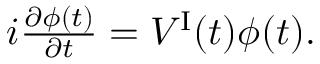Convert formula to latex. <formula><loc_0><loc_0><loc_500><loc_500>\begin{array} { r } { i \frac { \partial \phi ( t ) } { \partial t } = V ^ { I } ( t ) \phi ( t ) . } \end{array}</formula> 